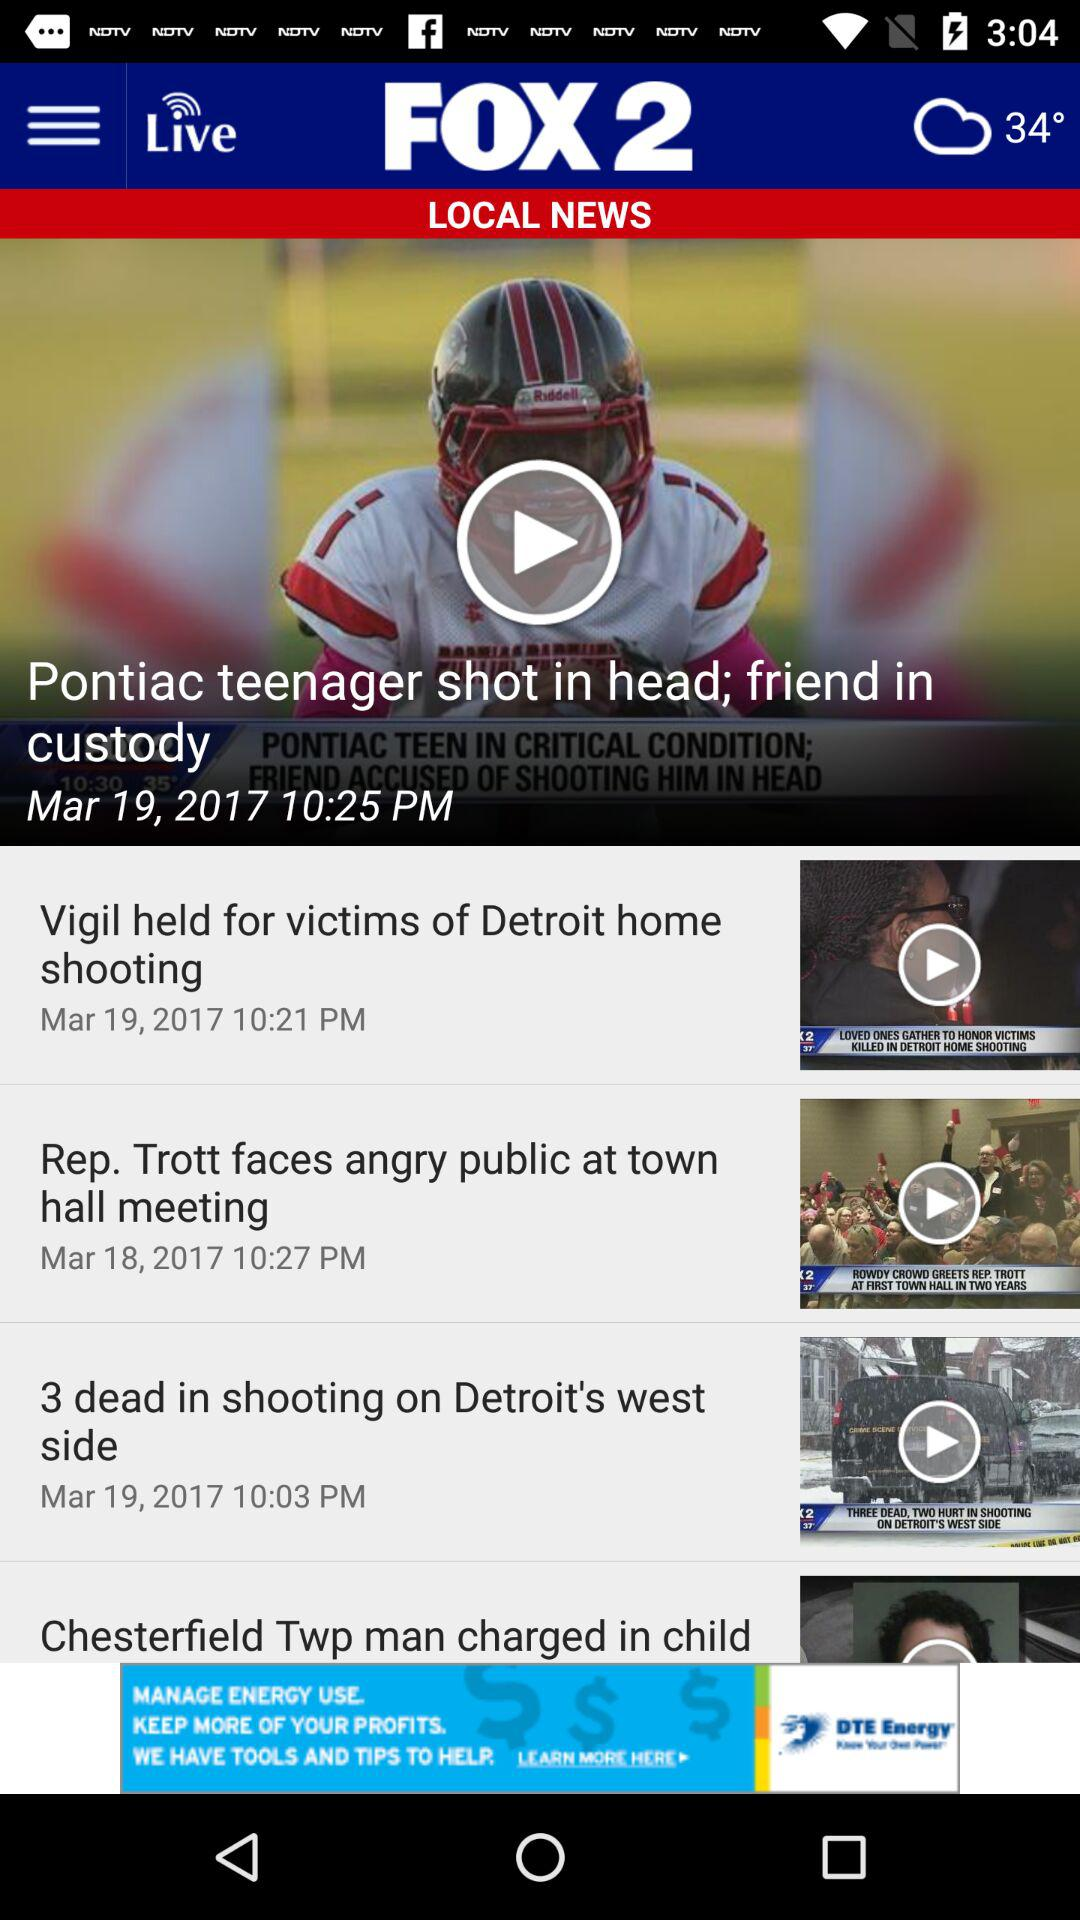What is the broadcast date of the news "Pontiac teenager shot in head; friend in custody"? The broadcast date of the news is March 19, 2017. 